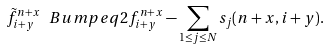Convert formula to latex. <formula><loc_0><loc_0><loc_500><loc_500>\tilde { f } ^ { n + x } _ { i + y } \ B u m p e q 2 f _ { i + y } ^ { n + x } - \sum _ { 1 \leq j \leq N } s _ { j } ( n + x , i + y ) .</formula> 